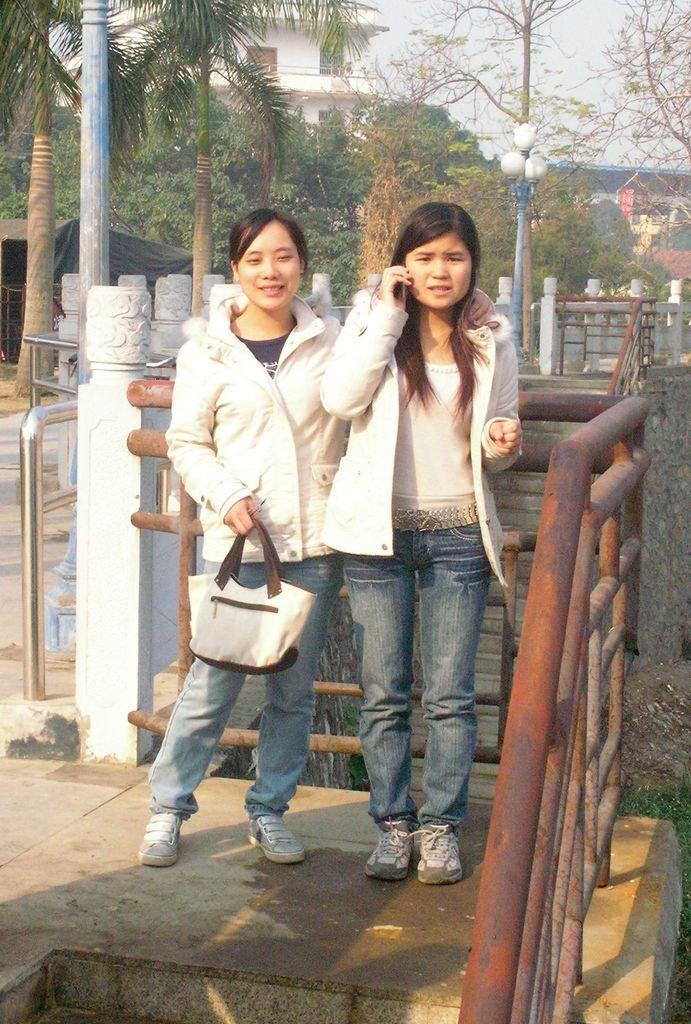In one or two sentences, can you explain what this image depicts? The image is outside of the city and it is very sunny. in the image there are woman standing, one woman is holding a handbag and other woman is holding a phone. In background there are street lights,trees,buildings and sky is on top. 